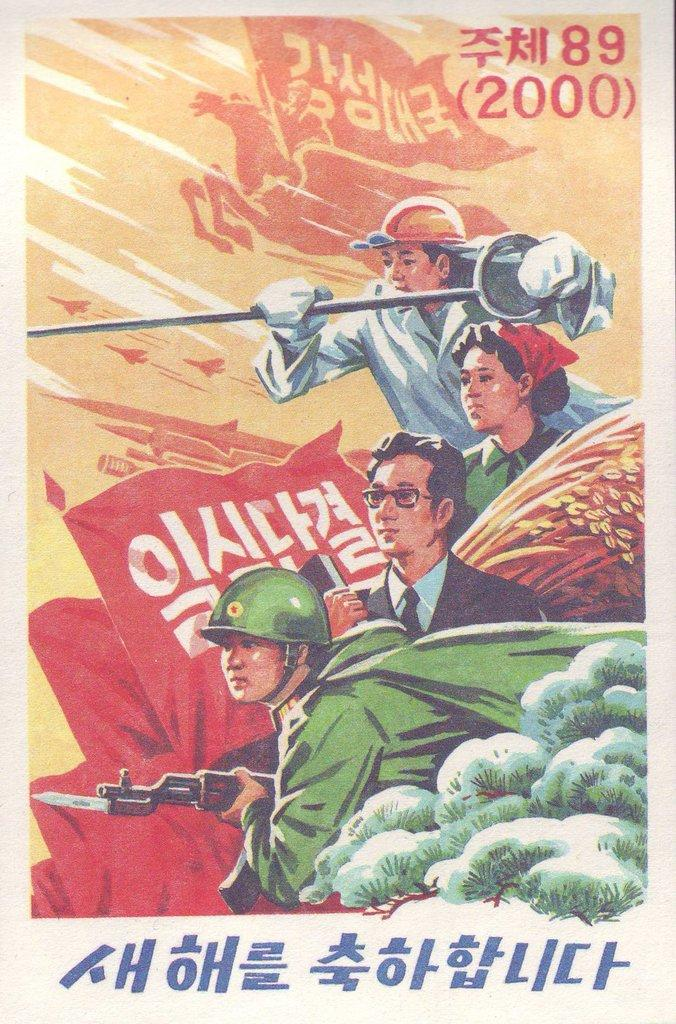<image>
Offer a succinct explanation of the picture presented. A soldier, lady, and civilian on a military poster dated 2000. 